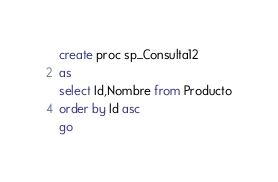Convert code to text. <code><loc_0><loc_0><loc_500><loc_500><_SQL_>create proc sp_Consulta12
as
select Id,Nombre from Producto
order by Id asc
go</code> 